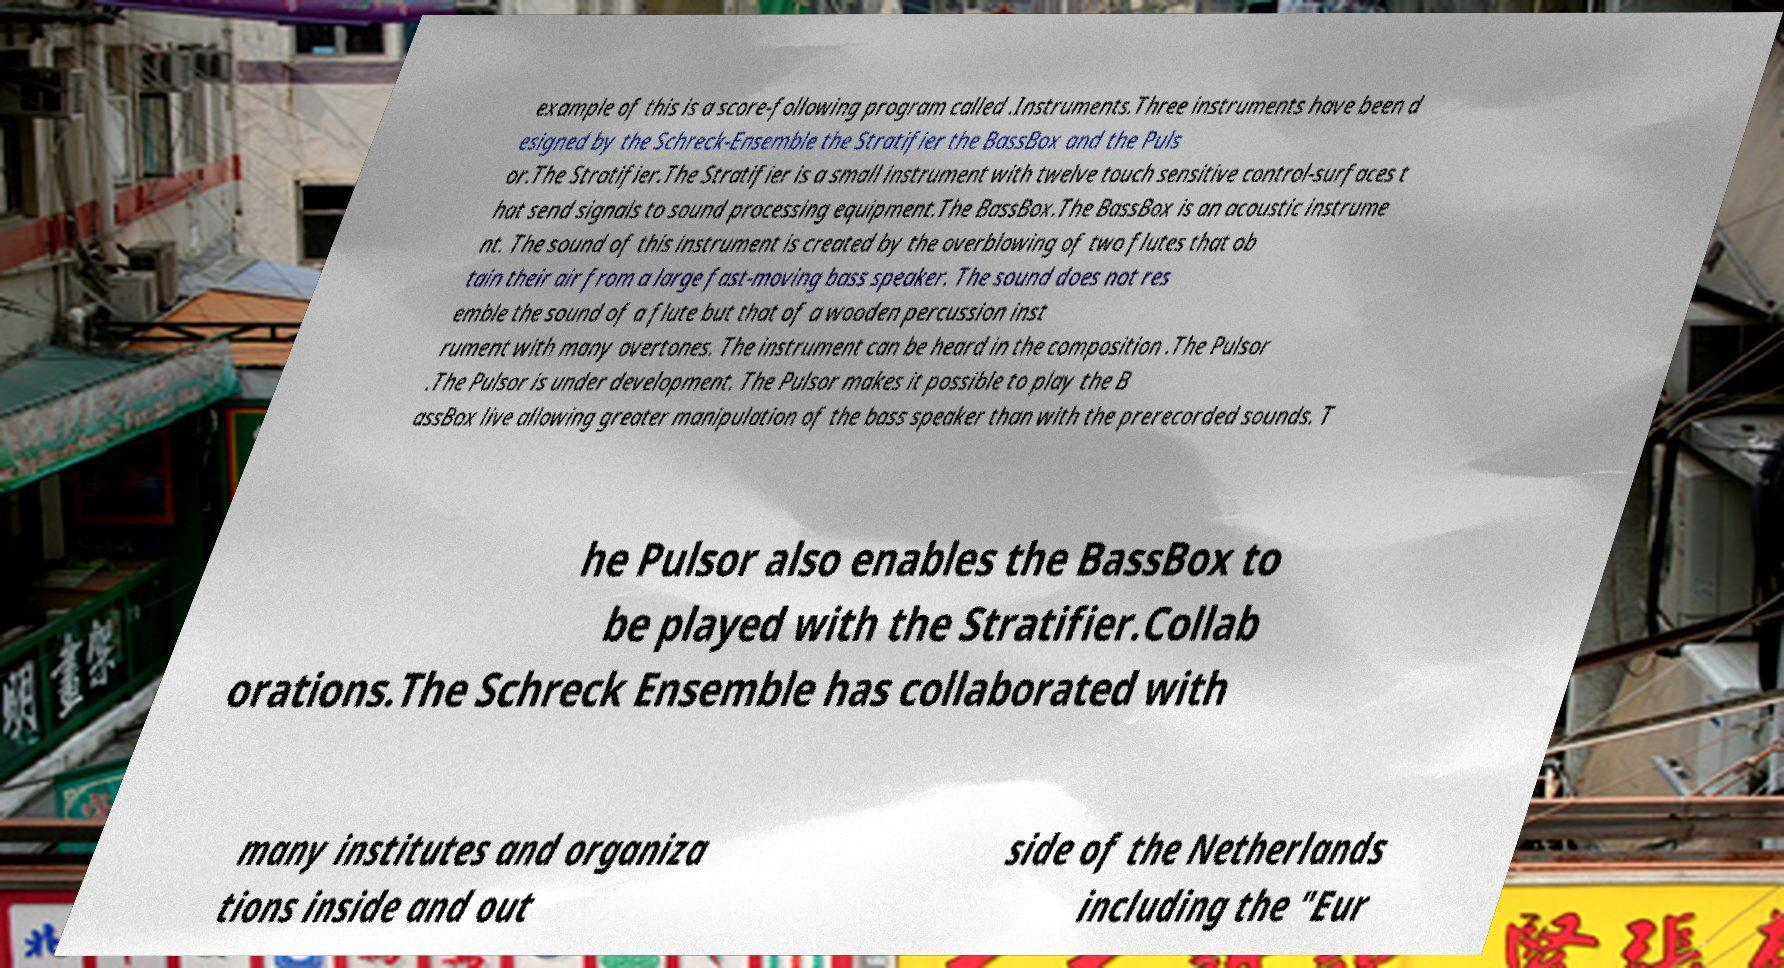Could you extract and type out the text from this image? example of this is a score-following program called .Instruments.Three instruments have been d esigned by the Schreck-Ensemble the Stratifier the BassBox and the Puls or.The Stratifier.The Stratifier is a small instrument with twelve touch sensitive control-surfaces t hat send signals to sound processing equipment.The BassBox.The BassBox is an acoustic instrume nt. The sound of this instrument is created by the overblowing of two flutes that ob tain their air from a large fast-moving bass speaker. The sound does not res emble the sound of a flute but that of a wooden percussion inst rument with many overtones. The instrument can be heard in the composition .The Pulsor .The Pulsor is under development. The Pulsor makes it possible to play the B assBox live allowing greater manipulation of the bass speaker than with the prerecorded sounds. T he Pulsor also enables the BassBox to be played with the Stratifier.Collab orations.The Schreck Ensemble has collaborated with many institutes and organiza tions inside and out side of the Netherlands including the "Eur 